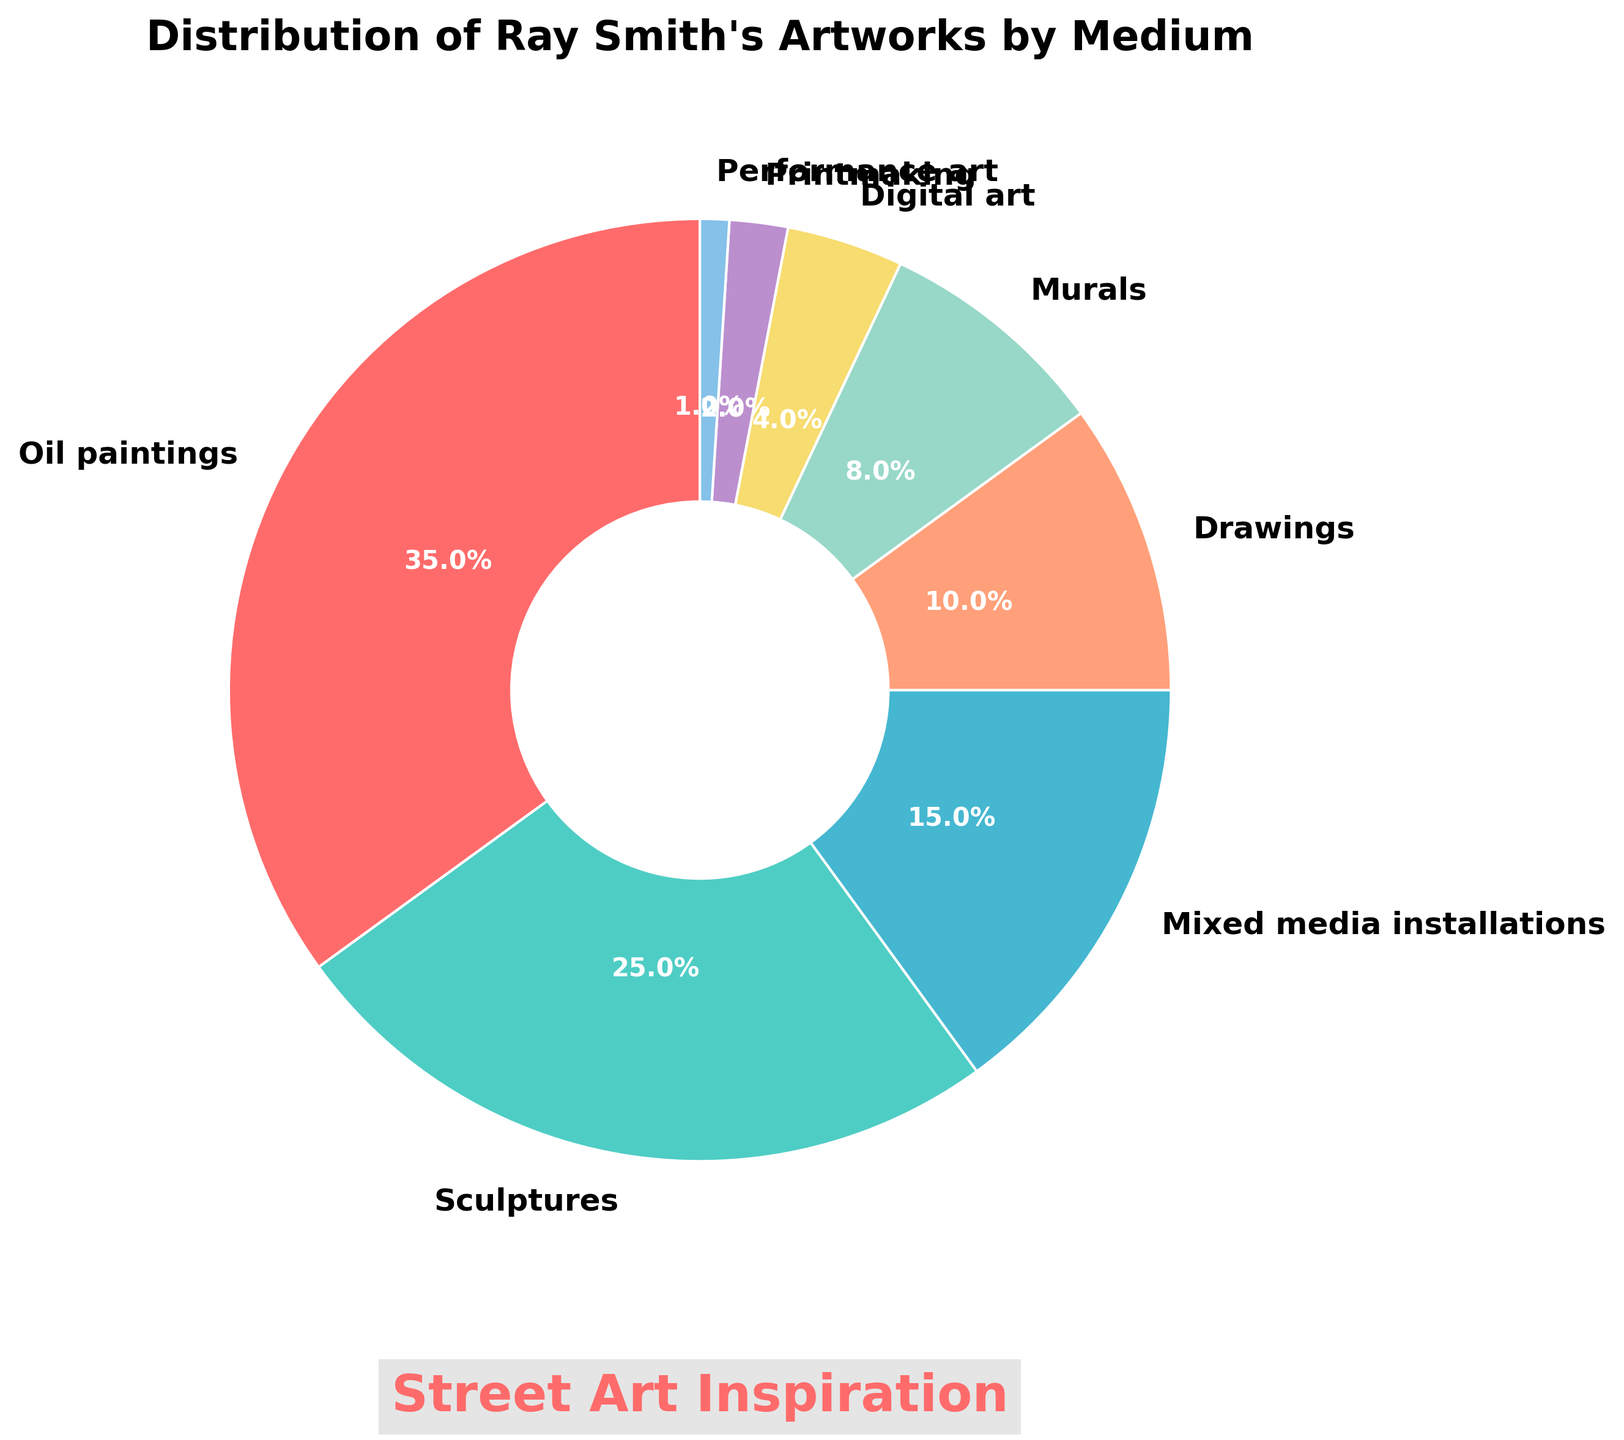What percentage of Ray Smith's artworks are oil paintings? Look at the pie chart slice labeled "Oil paintings" and note the percentage given.
Answer: 35% Compare the portions of sculptures and digital art. Which has a greater percentage and by how much? The pie chart shows "Sculptures" at 25% and "Digital art" at 4%. Subtract 4% from 25% to find the difference.
Answer: Sculptures by 21% What are the two least used mediums in Ray Smith's artworks? Identify the two smallest slices in the pie chart and read their labels.
Answer: Printmaking and Performance art What's the sum of the percentages for mixed media installations, drawings, and murals? Add the percentages given for "Mixed media installations" (15%), "Drawings" (10%), and "Murals" (8%) from the pie chart. 15 + 10 + 8 = 33%
Answer: 33% What's the second largest category after oil paintings? Find the largest slice first, which is "Oil paintings" at 35%, then look for the next largest slice, which is "Sculptures" at 25%.
Answer: Sculptures Which color represents murals in the pie chart? Look for the slice labeled "Murals" and note its color, which is a light yellowish hue.
Answer: light yellow Are digital arts and printmaking together more than mixed media installations? Add the percentages for "Digital art" (4%) and "Printmaking" (2%) and compare with "Mixed media installations" (15%). 4 + 2 = 6%, which is less than 15%.
Answer: No What's the total percentage of drawings, murals, and performance art combined? Add the percentages for "Drawings" (10%), "Murals" (8%), and "Performance art" (1%) from the pie chart. 10 + 8 + 1 = 19%
Answer: 19% What medium does the cyan color represent? Identify the slice colored in cyan in the pie chart and read its label.
Answer: Sculptures Among oil paintings, sculptures, and mixed media installations, which has the smallest share? Compare the percentages of "Oil paintings" (35%), "Sculptures" (25%), and "Mixed media installations" (15%) and identify the smallest one.
Answer: Mixed media installations 